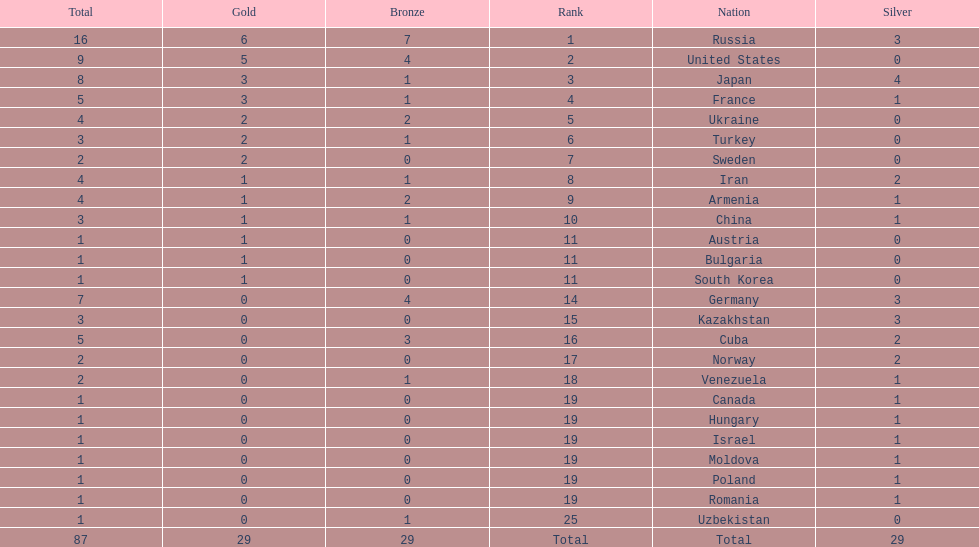Japan and france each won how many gold medals? 3. Help me parse the entirety of this table. {'header': ['Total', 'Gold', 'Bronze', 'Rank', 'Nation', 'Silver'], 'rows': [['16', '6', '7', '1', 'Russia', '3'], ['9', '5', '4', '2', 'United States', '0'], ['8', '3', '1', '3', 'Japan', '4'], ['5', '3', '1', '4', 'France', '1'], ['4', '2', '2', '5', 'Ukraine', '0'], ['3', '2', '1', '6', 'Turkey', '0'], ['2', '2', '0', '7', 'Sweden', '0'], ['4', '1', '1', '8', 'Iran', '2'], ['4', '1', '2', '9', 'Armenia', '1'], ['3', '1', '1', '10', 'China', '1'], ['1', '1', '0', '11', 'Austria', '0'], ['1', '1', '0', '11', 'Bulgaria', '0'], ['1', '1', '0', '11', 'South Korea', '0'], ['7', '0', '4', '14', 'Germany', '3'], ['3', '0', '0', '15', 'Kazakhstan', '3'], ['5', '0', '3', '16', 'Cuba', '2'], ['2', '0', '0', '17', 'Norway', '2'], ['2', '0', '1', '18', 'Venezuela', '1'], ['1', '0', '0', '19', 'Canada', '1'], ['1', '0', '0', '19', 'Hungary', '1'], ['1', '0', '0', '19', 'Israel', '1'], ['1', '0', '0', '19', 'Moldova', '1'], ['1', '0', '0', '19', 'Poland', '1'], ['1', '0', '0', '19', 'Romania', '1'], ['1', '0', '1', '25', 'Uzbekistan', '0'], ['87', '29', '29', 'Total', 'Total', '29']]} 